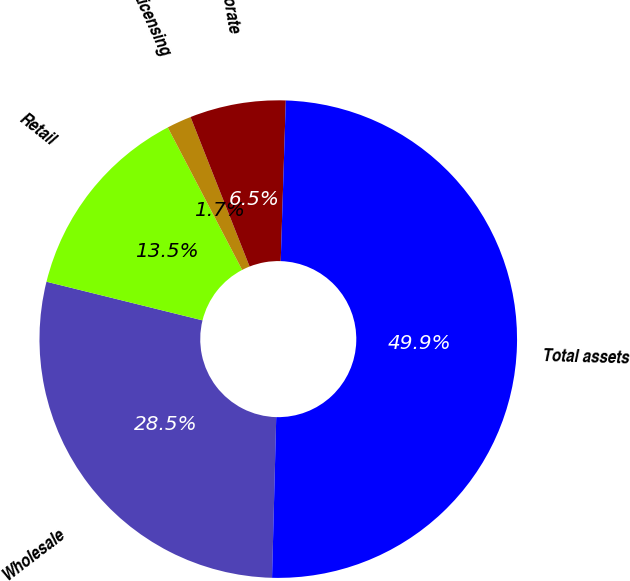<chart> <loc_0><loc_0><loc_500><loc_500><pie_chart><fcel>Wholesale<fcel>Retail<fcel>Licensing<fcel>Corporate<fcel>Total assets<nl><fcel>28.45%<fcel>13.48%<fcel>1.67%<fcel>6.49%<fcel>49.91%<nl></chart> 